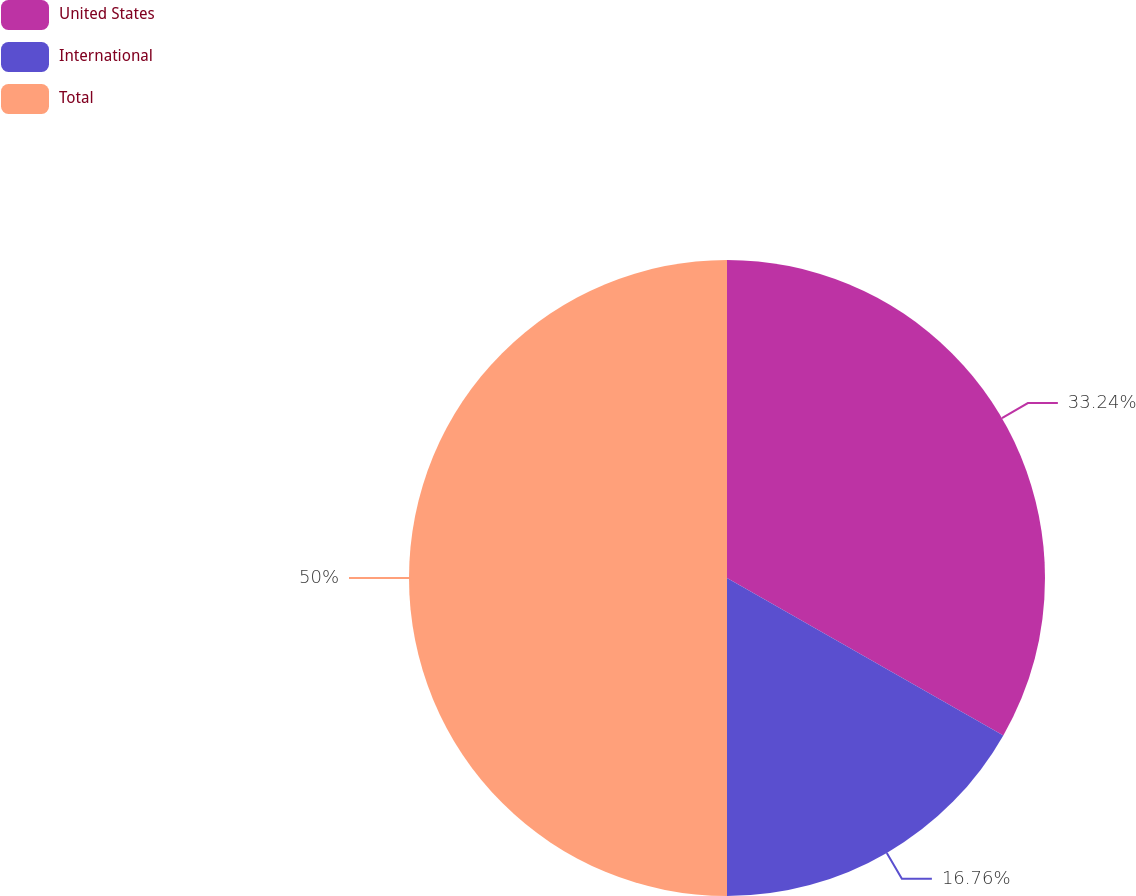Convert chart. <chart><loc_0><loc_0><loc_500><loc_500><pie_chart><fcel>United States<fcel>International<fcel>Total<nl><fcel>33.24%<fcel>16.76%<fcel>50.0%<nl></chart> 